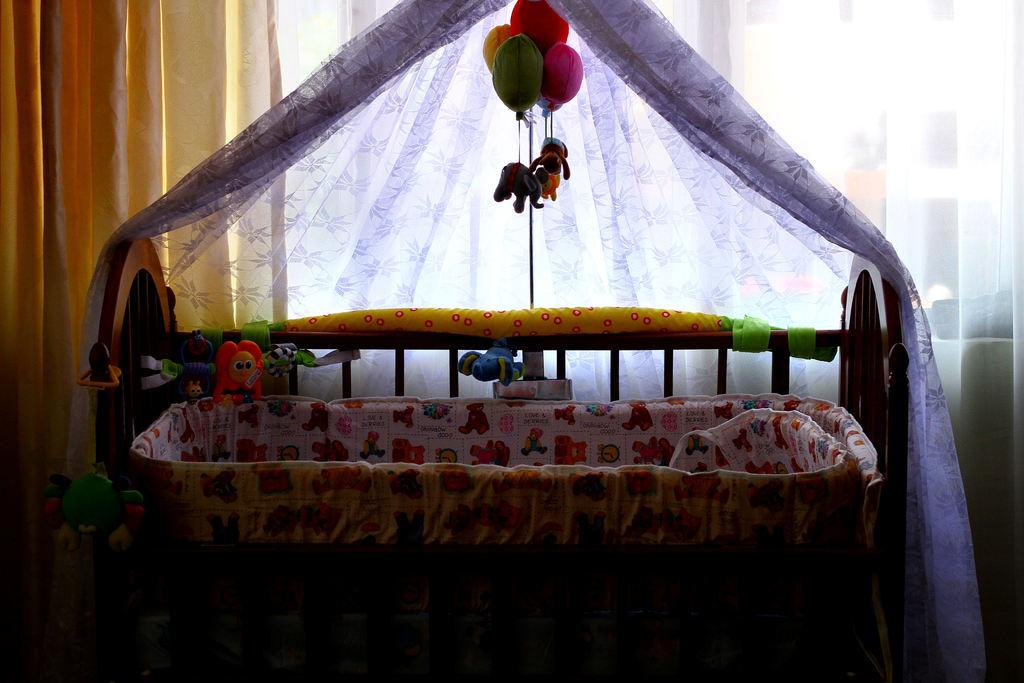What is the main object in the picture? There is a cradle in the picture. What type of window treatment is present in the picture? There are curtains in the picture. What can be seen in the picture that might be used for play? There are toys in the picture. Can you describe any other objects in the picture? There are other objects in the picture, but their specific details are not mentioned in the provided facts. What type of question is being asked by the rabbit in the picture? There is no rabbit present in the picture, so it is not possible to answer that question. 